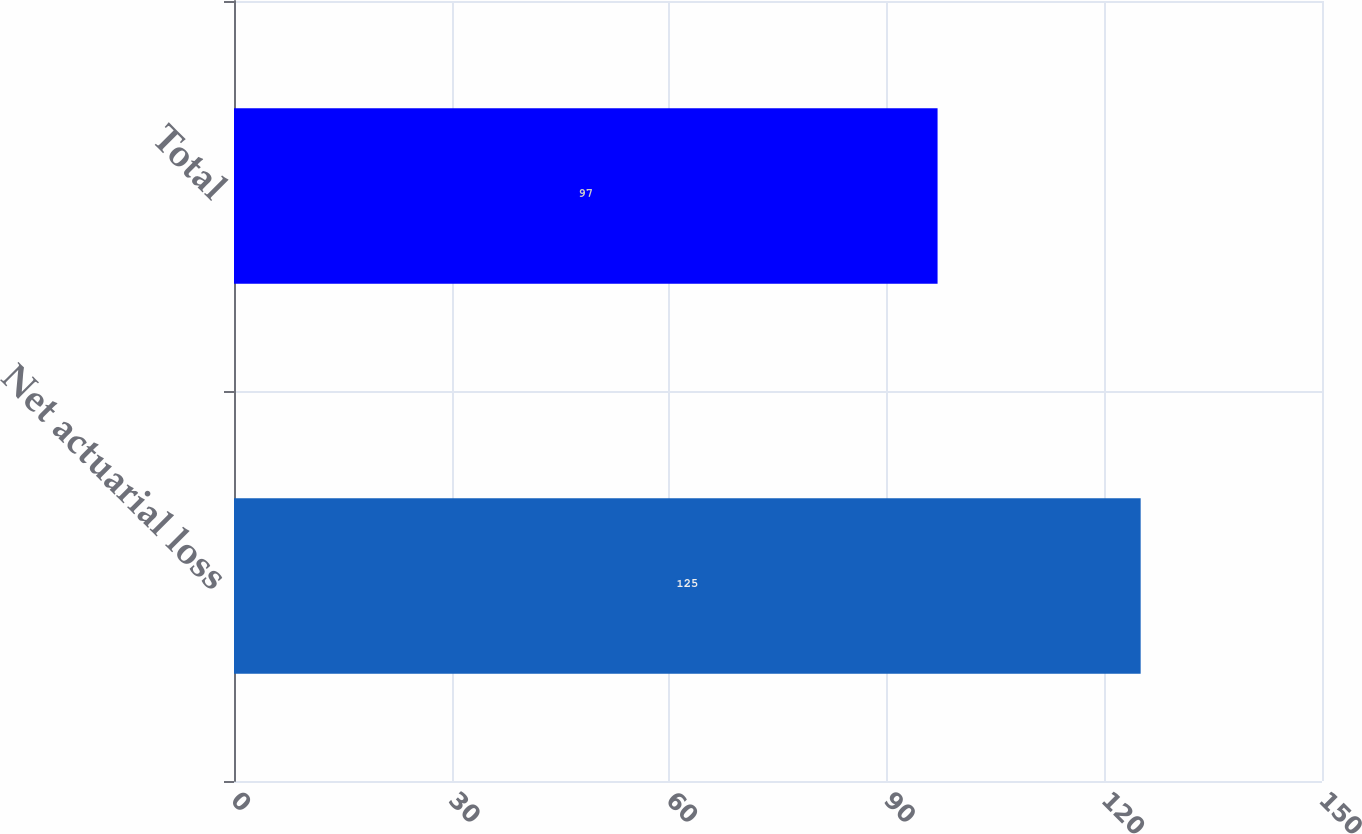<chart> <loc_0><loc_0><loc_500><loc_500><bar_chart><fcel>Net actuarial loss<fcel>Total<nl><fcel>125<fcel>97<nl></chart> 